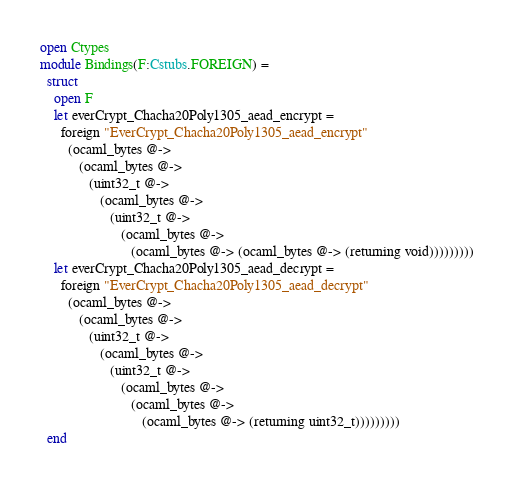<code> <loc_0><loc_0><loc_500><loc_500><_OCaml_>open Ctypes
module Bindings(F:Cstubs.FOREIGN) =
  struct
    open F
    let everCrypt_Chacha20Poly1305_aead_encrypt =
      foreign "EverCrypt_Chacha20Poly1305_aead_encrypt"
        (ocaml_bytes @->
           (ocaml_bytes @->
              (uint32_t @->
                 (ocaml_bytes @->
                    (uint32_t @->
                       (ocaml_bytes @->
                          (ocaml_bytes @-> (ocaml_bytes @-> (returning void)))))))))
    let everCrypt_Chacha20Poly1305_aead_decrypt =
      foreign "EverCrypt_Chacha20Poly1305_aead_decrypt"
        (ocaml_bytes @->
           (ocaml_bytes @->
              (uint32_t @->
                 (ocaml_bytes @->
                    (uint32_t @->
                       (ocaml_bytes @->
                          (ocaml_bytes @->
                             (ocaml_bytes @-> (returning uint32_t)))))))))
  end</code> 